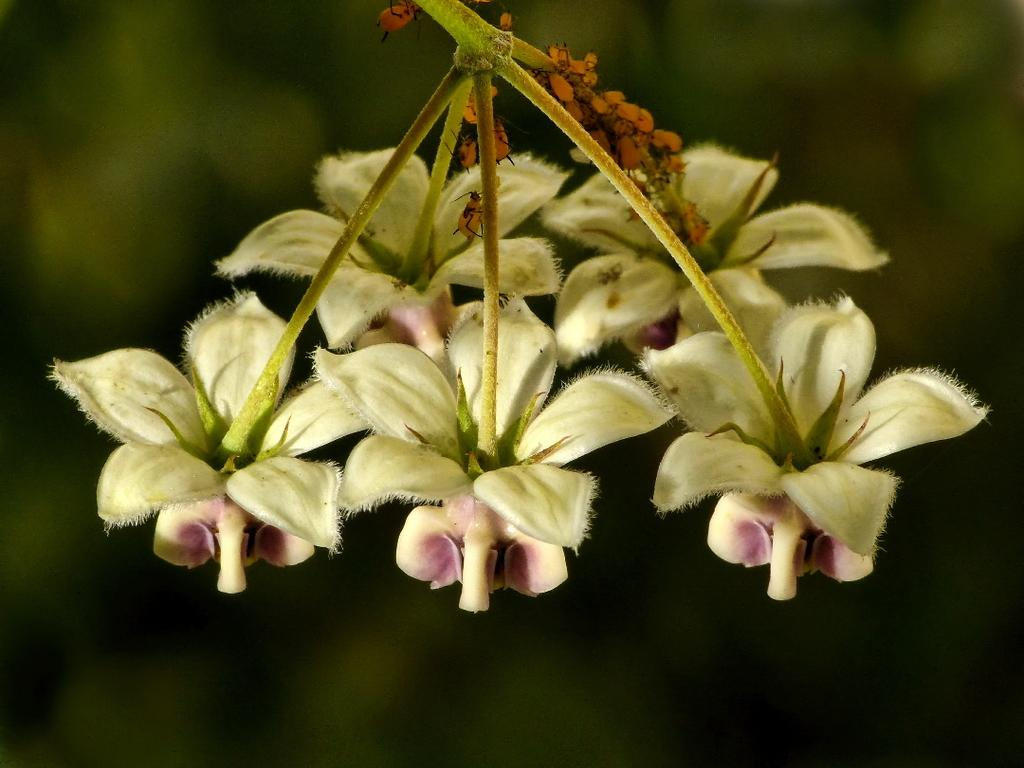What is present in the image? There is a plant in the image. What specific feature of the plant can be observed? The plant has flowers. What color are the flowers? The flowers are pink. Can you describe the background of the image? The background of the image is blurred. What type of stew is being cooked in the background of the image? There is no stew present in the image; it features a plant with pink flowers and a blurred background. Can you see a beam supporting the plant in the image? There is no beam visible in the image; it only shows a plant with flowers and a blurred background. 